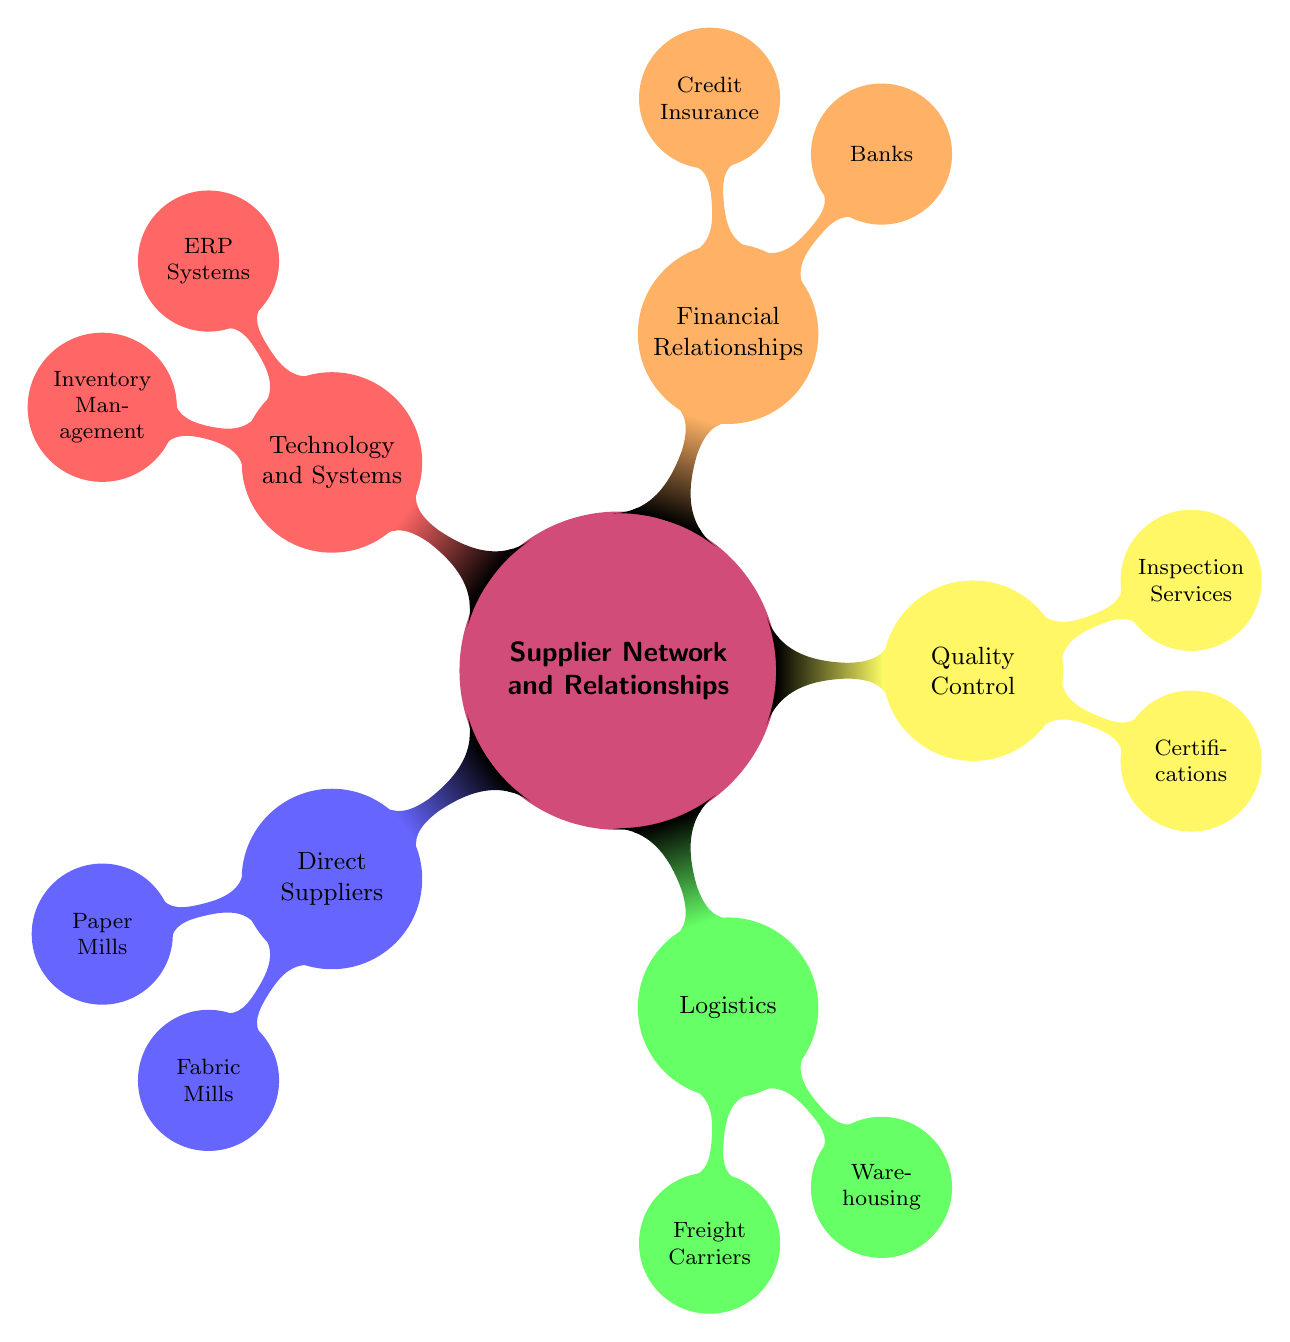What are the categories within the Supplier Network and Relationships? The diagram displays five main categories: Direct Suppliers, Logistics, Quality Control, Financial Relationships, and Technology and Systems.
Answer: Direct Suppliers, Logistics, Quality Control, Financial Relationships, Technology and Systems How many Direct Supplier categories are there? The Direct Suppliers section contains two main categories: Paper Mills and Fabric Mills, making a total of two categories.
Answer: 2 Who is listed under Paper Mills? The Paper Mills section includes three names: International Paper, Georgia-Pacific, and Nippon Paper Industries.
Answer: International Paper, Georgia-Pacific, Nippon Paper Industries Which Logistics category includes shipping services? The Freight Carriers category under Logistics is the one that encompasses shipping services, with specific examples like DHL, UPS, and FedEx.
Answer: Freight Carriers How many inspection service providers are listed under Quality Control? The Quality Control section has three listed inspection service providers: Intertek, SGS, and Bureau Veritas. Therefore, there are three providers.
Answer: 3 What are the banks represented in the Financial Relationships section? The banks listed in the Financial Relationships section are Wells Fargo, JPMorgan Chase, and Citibank.
Answer: Wells Fargo, JPMorgan Chase, Citibank Which category contains ERP Systems? The Technology and Systems category contains ERP Systems, which are important for managing enterprise resources.
Answer: Technology and Systems What type of software is included in the Inventory Management category? The Inventory Management Software listed includes Fishbowl, NetSuite, and Zoho Inventory, which are designed for inventory control.
Answer: Fishbowl, NetSuite, Zoho Inventory What certification is mentioned under Quality Control? The ISO 9001 certification is mentioned under the Certifications node of Quality Control.
Answer: ISO 9001 